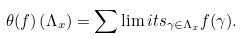Convert formula to latex. <formula><loc_0><loc_0><loc_500><loc_500>\theta ( f ) \left ( \Lambda _ { x } \right ) = \sum \lim i t s _ { \gamma \in \Lambda _ { x } } f ( \gamma ) .</formula> 